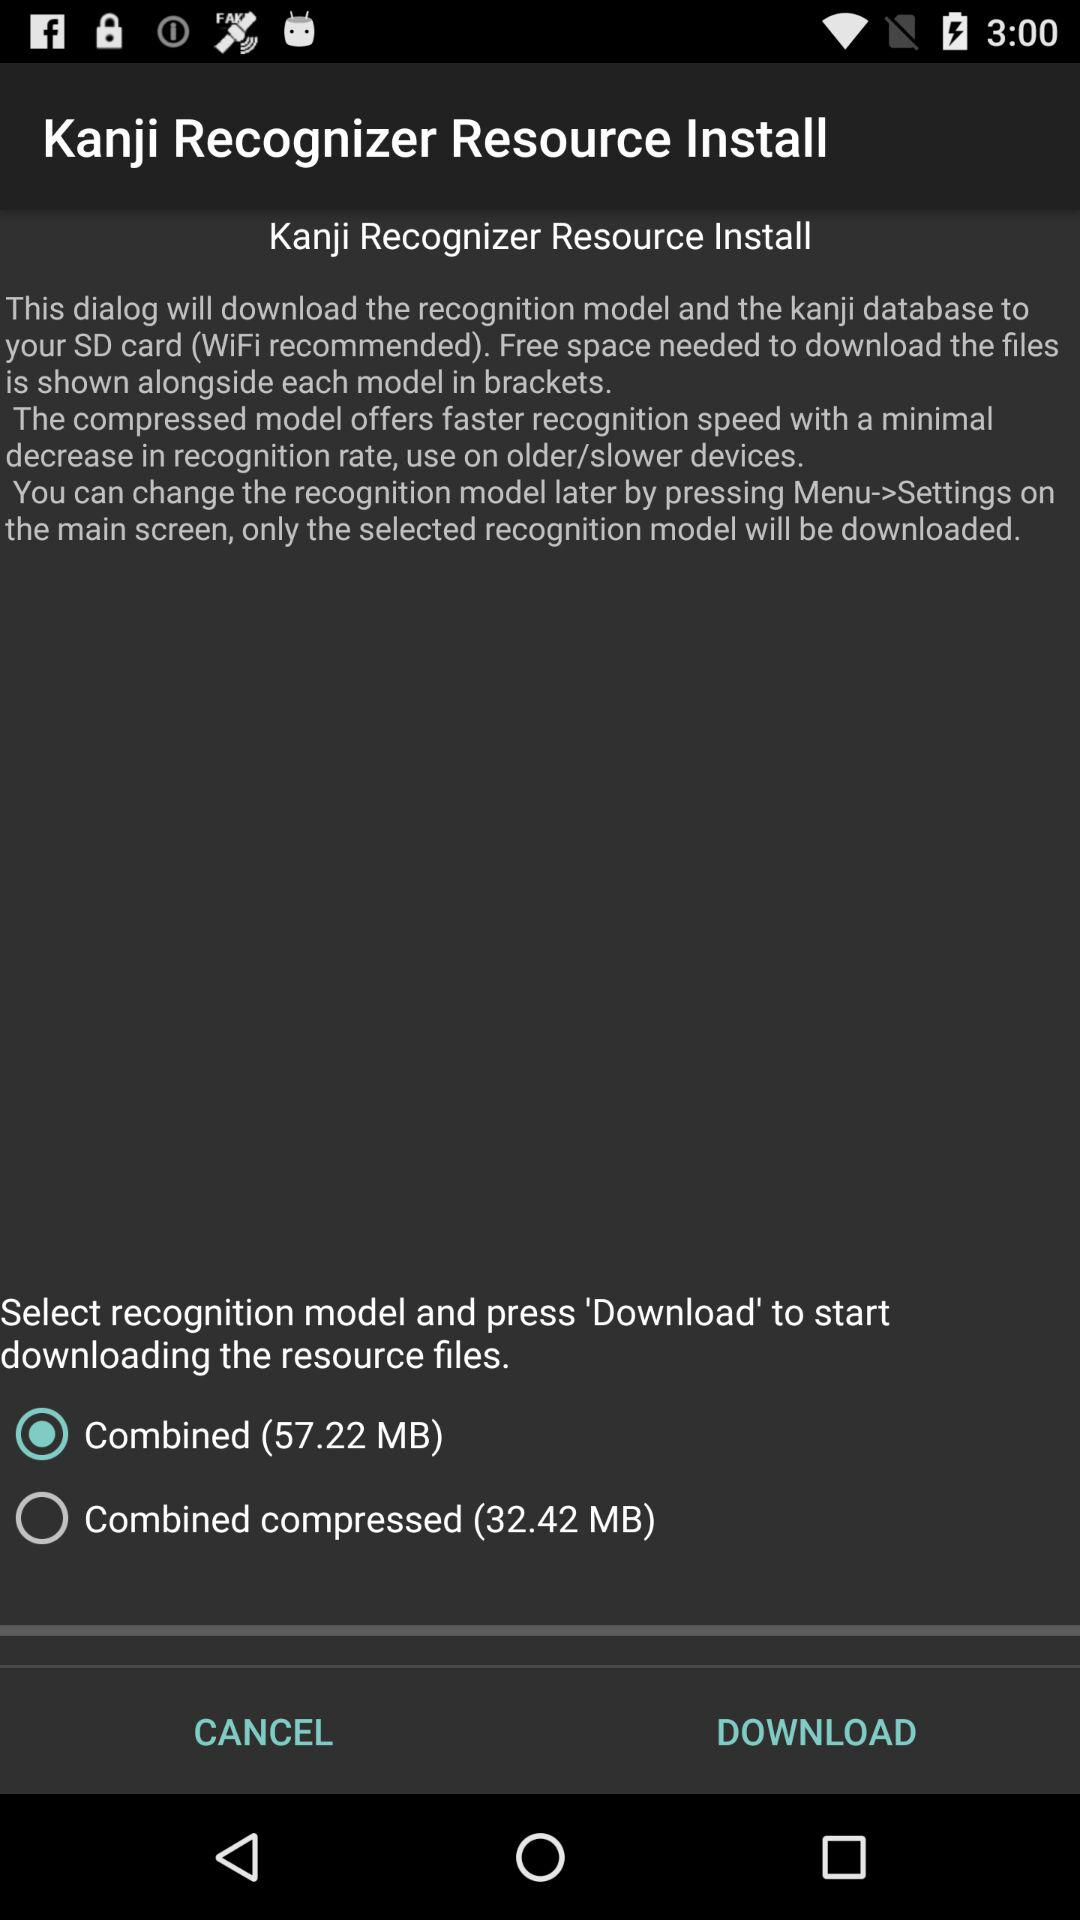How many models are available to download?
Answer the question using a single word or phrase. 2 